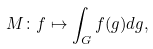Convert formula to latex. <formula><loc_0><loc_0><loc_500><loc_500>M \colon f \mapsto \int _ { G } f ( g ) d g ,</formula> 